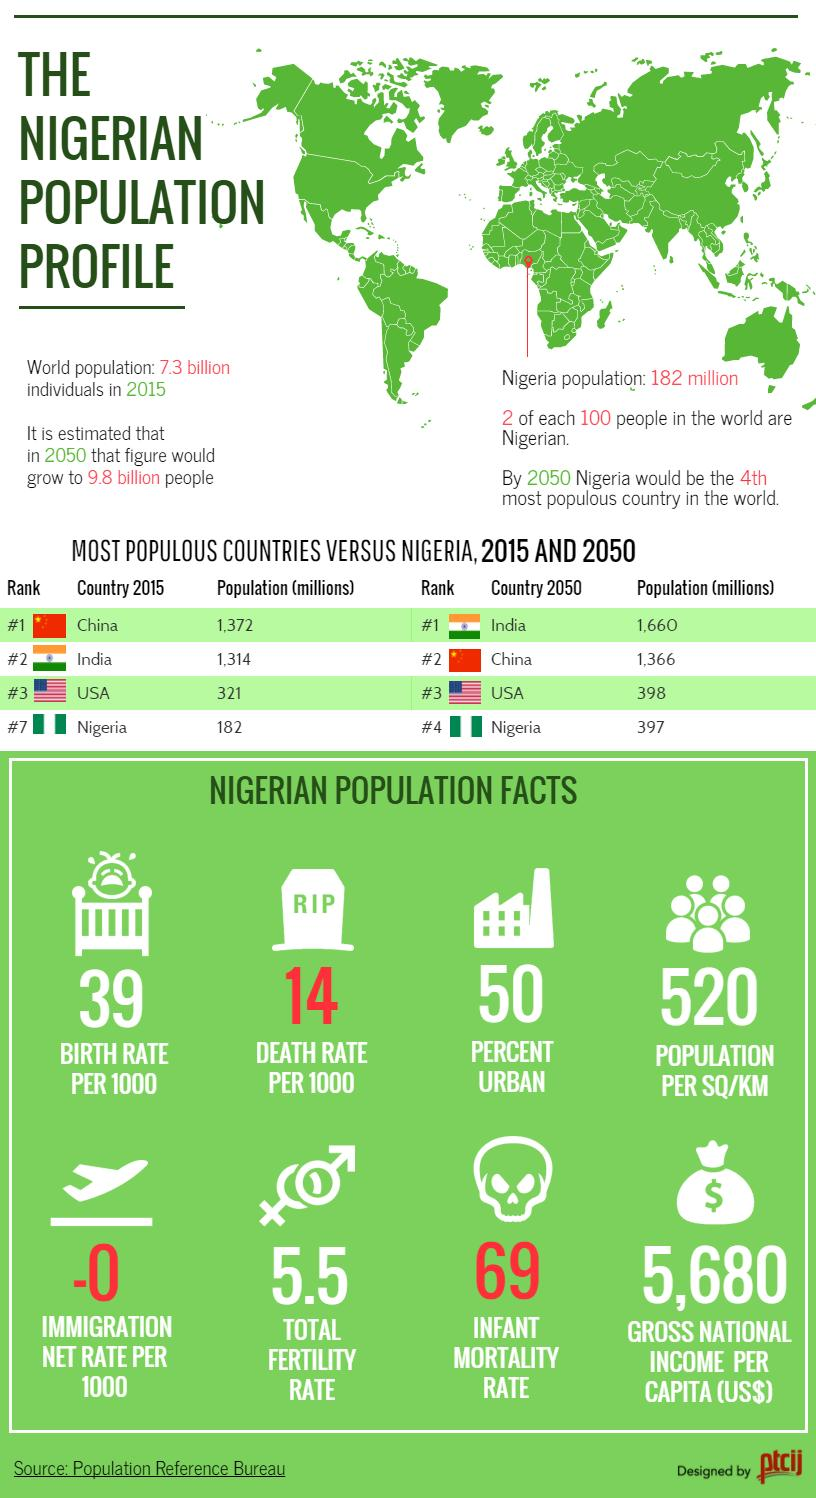Give some essential details in this illustration. The gross national income per capita of Nigeria is $5,680, in United States dollars. The death rate in Nigeria is 14 per 1000, indicating a high mortality rate in the country. By the year 2050, it is projected that India will surpass China in terms of population. The infant mortality rate in Nigeria is 69 deaths per 1,000 live births, according to recent data. The population per square kilometer is 520. 